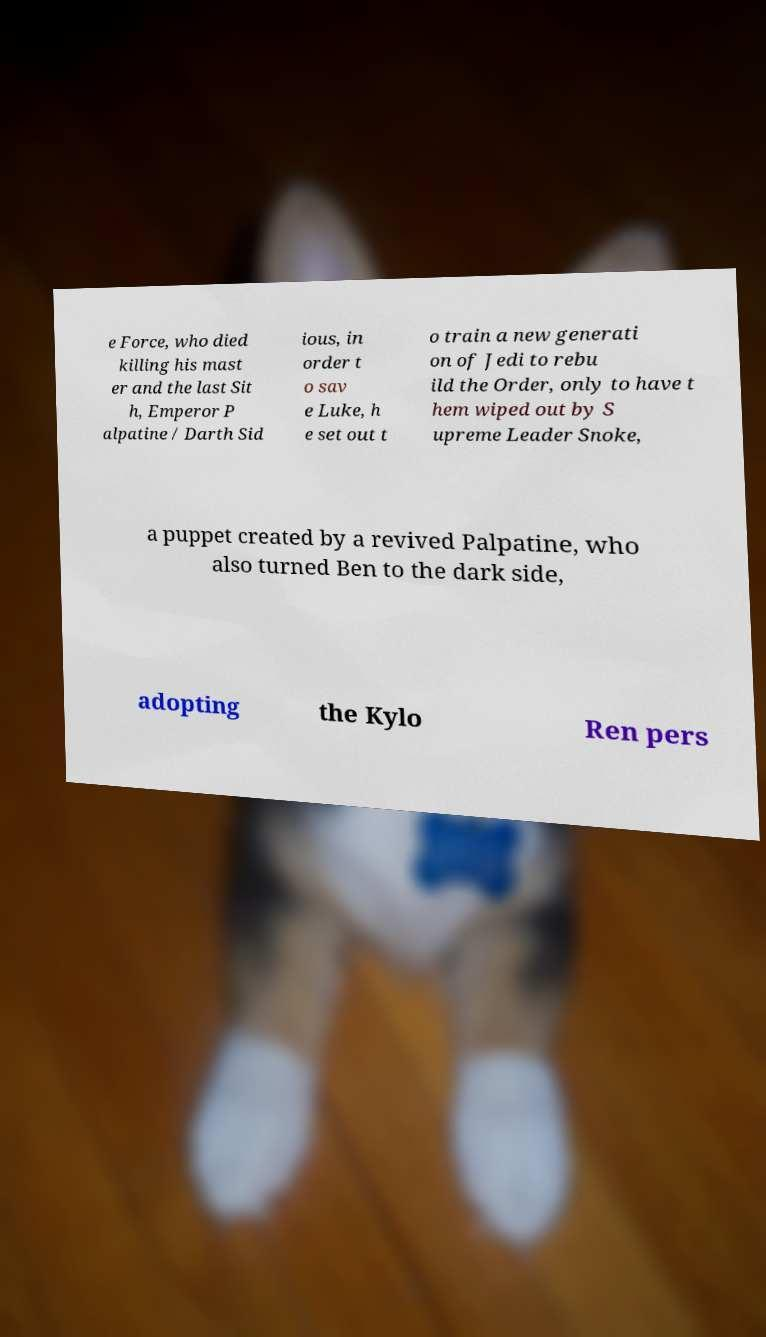What messages or text are displayed in this image? I need them in a readable, typed format. e Force, who died killing his mast er and the last Sit h, Emperor P alpatine / Darth Sid ious, in order t o sav e Luke, h e set out t o train a new generati on of Jedi to rebu ild the Order, only to have t hem wiped out by S upreme Leader Snoke, a puppet created by a revived Palpatine, who also turned Ben to the dark side, adopting the Kylo Ren pers 